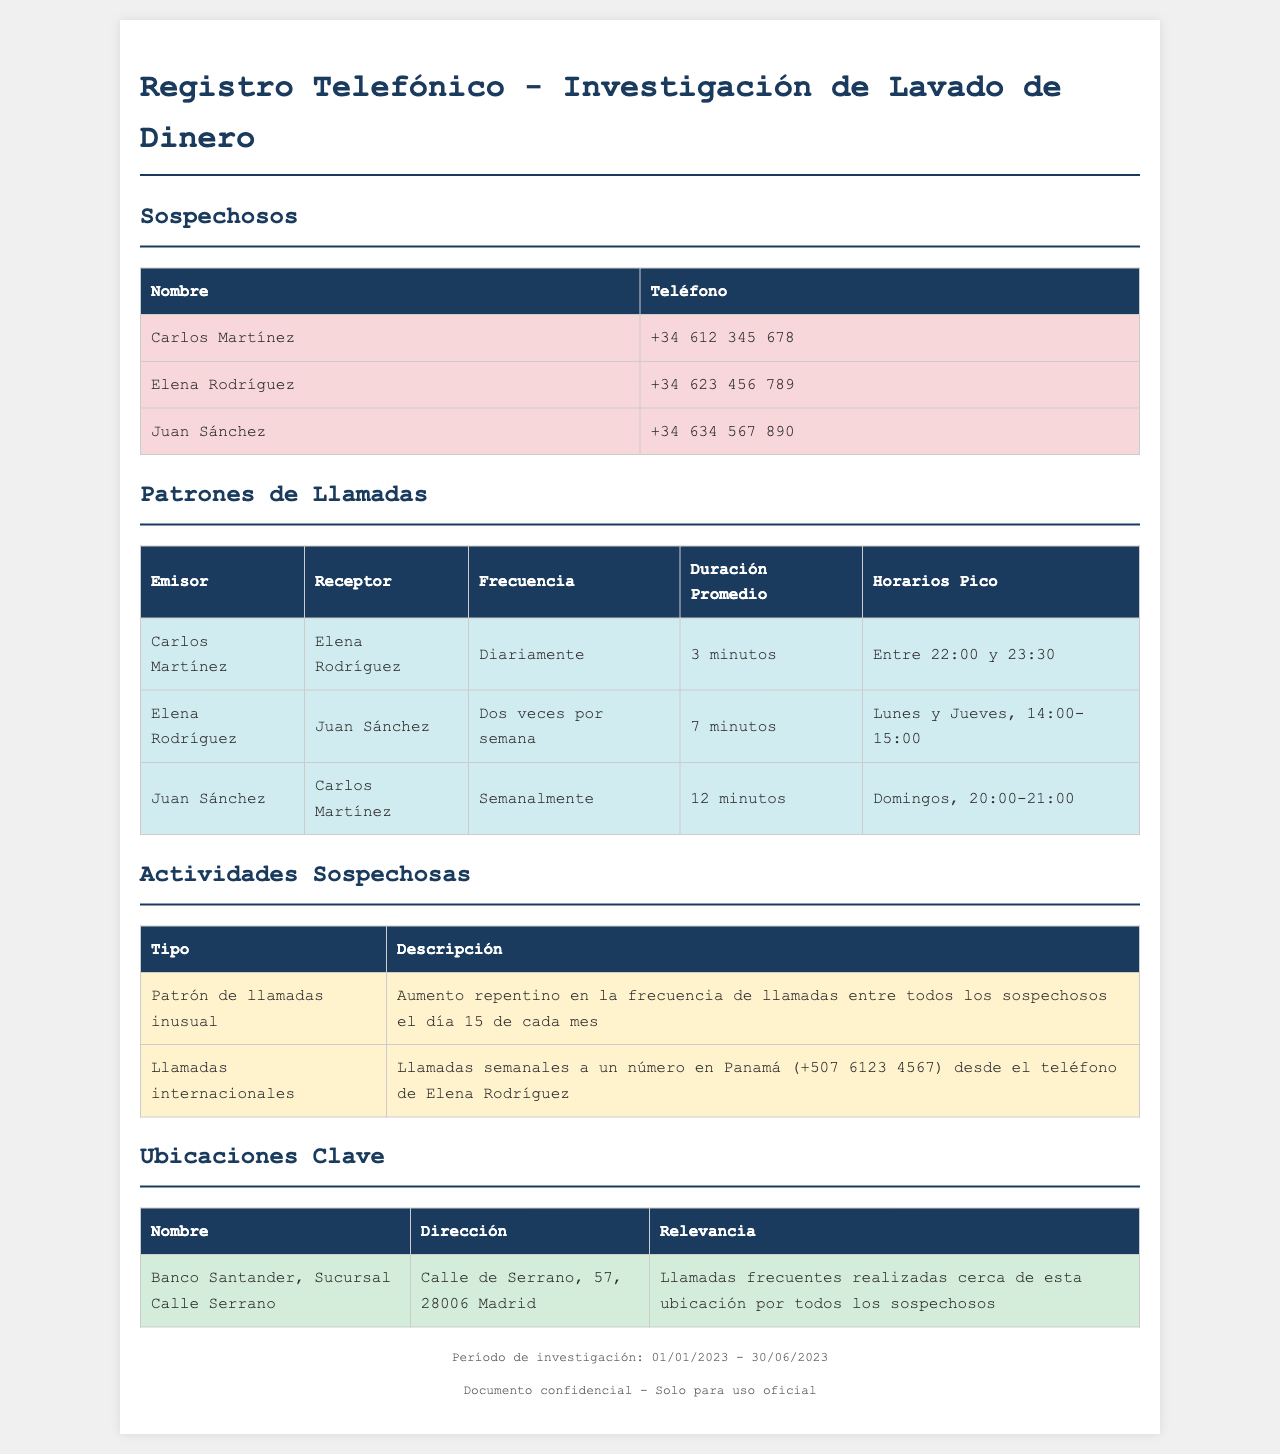¿Cuáles son los nombres de los tres sospechosos? Los nombres de los sospechosos son listados en la tabla de Sospechosos en el documento.
Answer: Carlos Martínez, Elena Rodríguez, Juan Sánchez ¿Cuál es la duración promedio de las llamadas entre Carlos Martínez y Elena Rodríguez? La duración promedio se encuentra en la tabla de Patrones de Llamadas bajo el par de Carlos Martínez y Elena Rodríguez.
Answer: 3 minutos ¿Con qué frecuencia se comunican Elena Rodríguez y Juan Sánchez? La frecuencia de la comunicación se puede observar en la tabla de Patrones de Llamadas.
Answer: Dos veces por semana ¿Cuándo ocurre el aumento repentino en la frecuencia de llamadas entre los sospechosos? Esta información se detalla en la sección de Actividades Sospechosas, que describe patrones inusuales.
Answer: El día 15 de cada mes ¿Cuál es el número de teléfono utilizado por Elena Rodríguez? El número de teléfono de Elena Rodríguez se menciona en la tabla de Sospechosos del documento.
Answer: +34 623 456 789 ¿Cuál es el horario pico de las llamadas entre Carlos Martínez y Elena Rodríguez? El horario pico se encuentra en la tabla de Patrones de Llamadas y muestra los tiempos de comunicación frecuentes.
Answer: Entre 22:00 y 23:30 ¿Qué tipo de actividad sospechosa se identifica en relación con Elena Rodríguez? La actividad sospechosa se describe en la sección de Actividades Sospechosas en relación a las comunicaciones internacionales.
Answer: Llamadas internacionales ¿Cuál es la dirección del banco mencionado? La dirección del banco se proporciona en la sección de Ubicaciones Clave del documento.
Answer: Calle de Serrano, 57, 28006 Madrid ¿Cuál es la duración promedio de las llamadas entre Juan Sánchez y Carlos Martínez? Esta información se localiza en la tabla de Patrones de Llamadas que muestra la duración de las comunicaciones.
Answer: 12 minutos 